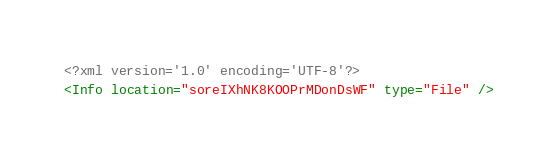<code> <loc_0><loc_0><loc_500><loc_500><_XML_><?xml version='1.0' encoding='UTF-8'?>
<Info location="soreIXhNK8KOOPrMDonDsWF" type="File" /></code> 